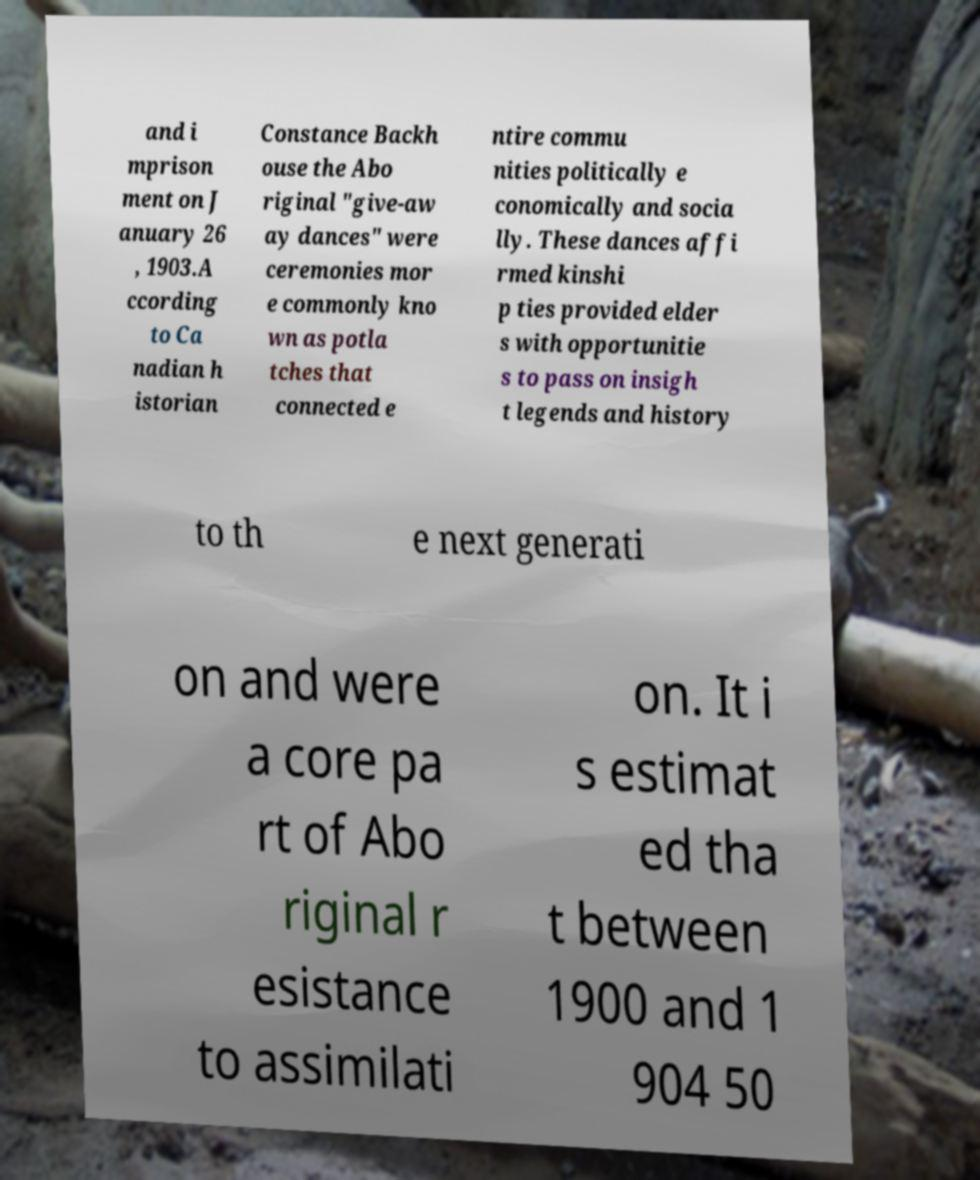Could you extract and type out the text from this image? and i mprison ment on J anuary 26 , 1903.A ccording to Ca nadian h istorian Constance Backh ouse the Abo riginal "give-aw ay dances" were ceremonies mor e commonly kno wn as potla tches that connected e ntire commu nities politically e conomically and socia lly. These dances affi rmed kinshi p ties provided elder s with opportunitie s to pass on insigh t legends and history to th e next generati on and were a core pa rt of Abo riginal r esistance to assimilati on. It i s estimat ed tha t between 1900 and 1 904 50 